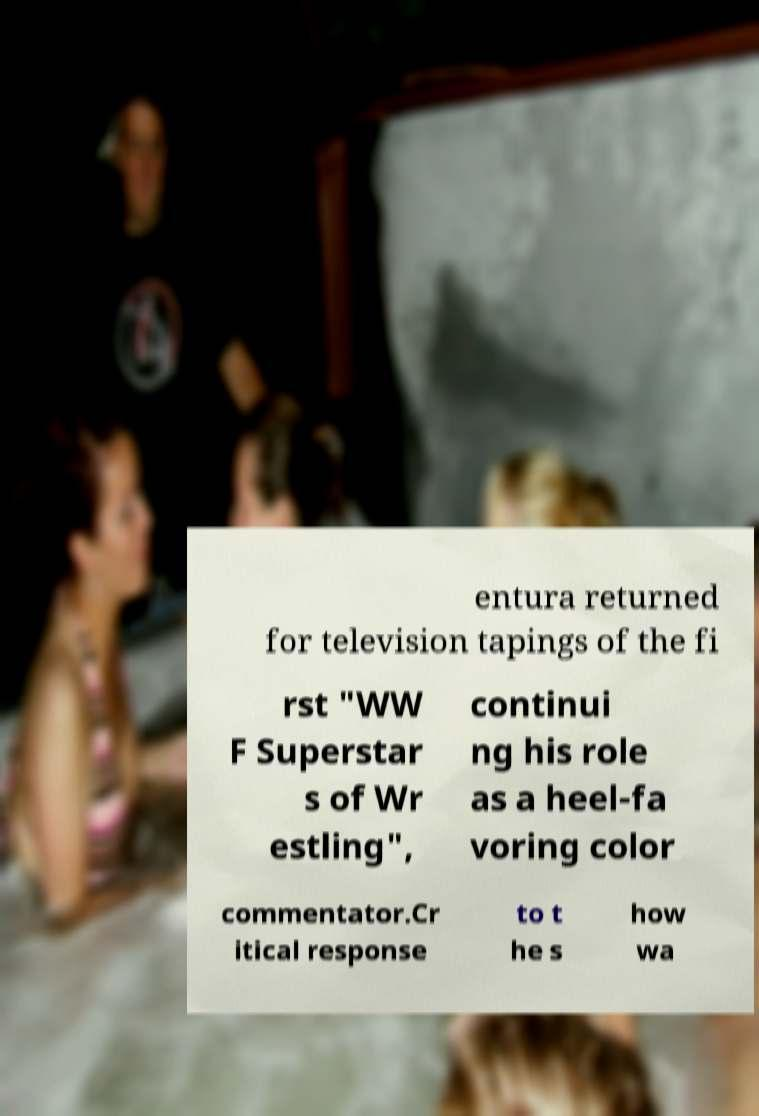I need the written content from this picture converted into text. Can you do that? entura returned for television tapings of the fi rst "WW F Superstar s of Wr estling", continui ng his role as a heel-fa voring color commentator.Cr itical response to t he s how wa 